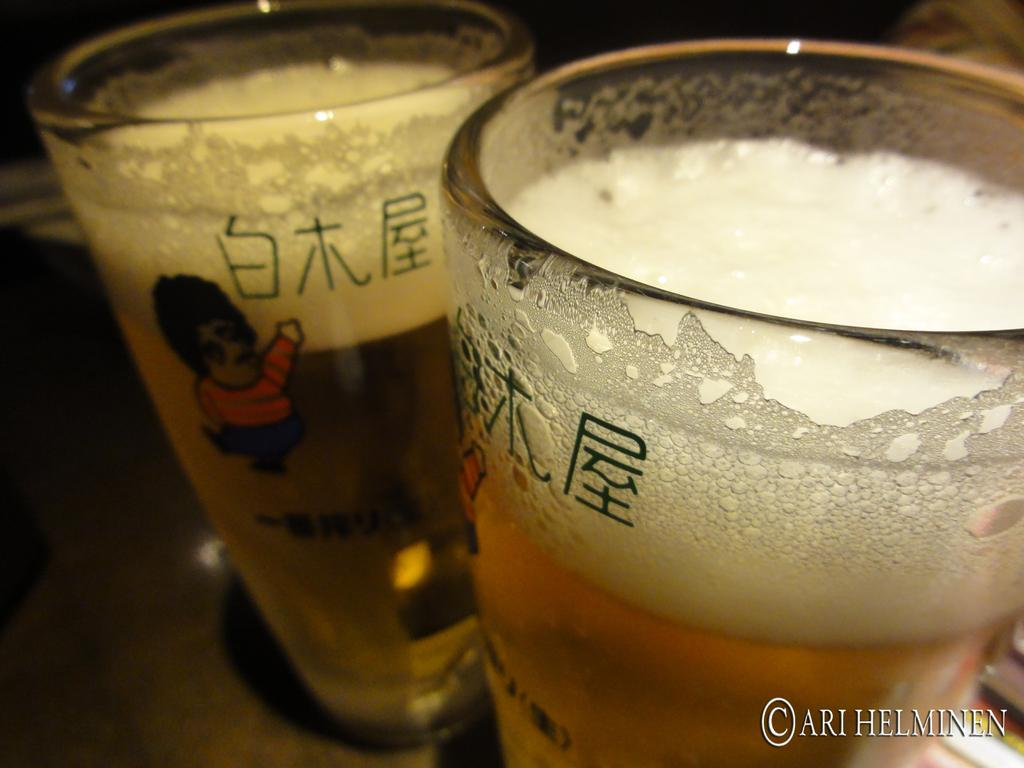How many glasses are visible in the image? There are two glasses in the image. What is inside each glass? Each glass contains a bear and foam. Where are the glasses located? The glasses are placed on a table. How many rabbits can be seen in the image? There are no rabbits present in the image. What type of worm is visible in the image? There are no worms present in the image. 